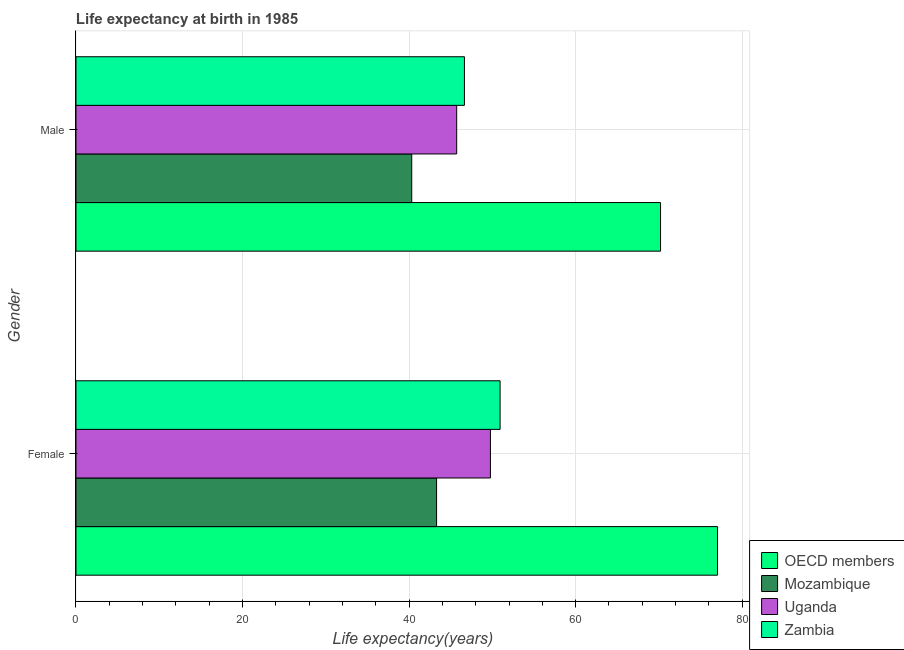How many different coloured bars are there?
Offer a very short reply. 4. Are the number of bars per tick equal to the number of legend labels?
Provide a succinct answer. Yes. How many bars are there on the 1st tick from the top?
Provide a succinct answer. 4. How many bars are there on the 1st tick from the bottom?
Provide a succinct answer. 4. What is the life expectancy(male) in Zambia?
Ensure brevity in your answer.  46.65. Across all countries, what is the maximum life expectancy(female)?
Provide a short and direct response. 77.03. Across all countries, what is the minimum life expectancy(female)?
Your response must be concise. 43.3. In which country was the life expectancy(male) minimum?
Give a very brief answer. Mozambique. What is the total life expectancy(female) in the graph?
Your response must be concise. 221.03. What is the difference between the life expectancy(female) in OECD members and that in Zambia?
Give a very brief answer. 26.11. What is the difference between the life expectancy(male) in Uganda and the life expectancy(female) in OECD members?
Provide a short and direct response. -31.32. What is the average life expectancy(male) per country?
Keep it short and to the point. 50.72. What is the difference between the life expectancy(female) and life expectancy(male) in OECD members?
Provide a short and direct response. 6.84. What is the ratio of the life expectancy(male) in Uganda to that in OECD members?
Give a very brief answer. 0.65. In how many countries, is the life expectancy(female) greater than the average life expectancy(female) taken over all countries?
Give a very brief answer. 1. What does the 1st bar from the top in Male represents?
Make the answer very short. Zambia. What does the 4th bar from the bottom in Male represents?
Offer a terse response. Zambia. How many bars are there?
Offer a terse response. 8. Are all the bars in the graph horizontal?
Your answer should be compact. Yes. How many countries are there in the graph?
Ensure brevity in your answer.  4. What is the difference between two consecutive major ticks on the X-axis?
Your answer should be very brief. 20. Does the graph contain grids?
Give a very brief answer. Yes. Where does the legend appear in the graph?
Ensure brevity in your answer.  Bottom right. How many legend labels are there?
Ensure brevity in your answer.  4. How are the legend labels stacked?
Your answer should be very brief. Vertical. What is the title of the graph?
Offer a terse response. Life expectancy at birth in 1985. Does "China" appear as one of the legend labels in the graph?
Your answer should be very brief. No. What is the label or title of the X-axis?
Your answer should be very brief. Life expectancy(years). What is the label or title of the Y-axis?
Keep it short and to the point. Gender. What is the Life expectancy(years) of OECD members in Female?
Make the answer very short. 77.03. What is the Life expectancy(years) of Mozambique in Female?
Give a very brief answer. 43.3. What is the Life expectancy(years) in Uganda in Female?
Your answer should be very brief. 49.77. What is the Life expectancy(years) in Zambia in Female?
Provide a short and direct response. 50.93. What is the Life expectancy(years) of OECD members in Male?
Your answer should be very brief. 70.19. What is the Life expectancy(years) of Mozambique in Male?
Make the answer very short. 40.32. What is the Life expectancy(years) of Uganda in Male?
Keep it short and to the point. 45.72. What is the Life expectancy(years) of Zambia in Male?
Ensure brevity in your answer.  46.65. Across all Gender, what is the maximum Life expectancy(years) of OECD members?
Make the answer very short. 77.03. Across all Gender, what is the maximum Life expectancy(years) of Mozambique?
Make the answer very short. 43.3. Across all Gender, what is the maximum Life expectancy(years) in Uganda?
Your response must be concise. 49.77. Across all Gender, what is the maximum Life expectancy(years) of Zambia?
Your answer should be compact. 50.93. Across all Gender, what is the minimum Life expectancy(years) in OECD members?
Your answer should be compact. 70.19. Across all Gender, what is the minimum Life expectancy(years) in Mozambique?
Your answer should be compact. 40.32. Across all Gender, what is the minimum Life expectancy(years) in Uganda?
Provide a succinct answer. 45.72. Across all Gender, what is the minimum Life expectancy(years) in Zambia?
Make the answer very short. 46.65. What is the total Life expectancy(years) of OECD members in the graph?
Make the answer very short. 147.23. What is the total Life expectancy(years) of Mozambique in the graph?
Your answer should be compact. 83.62. What is the total Life expectancy(years) of Uganda in the graph?
Offer a very short reply. 95.48. What is the total Life expectancy(years) of Zambia in the graph?
Offer a very short reply. 97.57. What is the difference between the Life expectancy(years) in OECD members in Female and that in Male?
Make the answer very short. 6.84. What is the difference between the Life expectancy(years) of Mozambique in Female and that in Male?
Keep it short and to the point. 2.98. What is the difference between the Life expectancy(years) of Uganda in Female and that in Male?
Offer a very short reply. 4.05. What is the difference between the Life expectancy(years) in Zambia in Female and that in Male?
Your answer should be compact. 4.28. What is the difference between the Life expectancy(years) of OECD members in Female and the Life expectancy(years) of Mozambique in Male?
Your answer should be compact. 36.72. What is the difference between the Life expectancy(years) of OECD members in Female and the Life expectancy(years) of Uganda in Male?
Keep it short and to the point. 31.32. What is the difference between the Life expectancy(years) in OECD members in Female and the Life expectancy(years) in Zambia in Male?
Provide a short and direct response. 30.39. What is the difference between the Life expectancy(years) in Mozambique in Female and the Life expectancy(years) in Uganda in Male?
Provide a succinct answer. -2.41. What is the difference between the Life expectancy(years) of Mozambique in Female and the Life expectancy(years) of Zambia in Male?
Provide a short and direct response. -3.35. What is the difference between the Life expectancy(years) in Uganda in Female and the Life expectancy(years) in Zambia in Male?
Provide a succinct answer. 3.12. What is the average Life expectancy(years) of OECD members per Gender?
Your answer should be very brief. 73.61. What is the average Life expectancy(years) of Mozambique per Gender?
Your answer should be compact. 41.81. What is the average Life expectancy(years) of Uganda per Gender?
Your answer should be very brief. 47.74. What is the average Life expectancy(years) of Zambia per Gender?
Provide a short and direct response. 48.79. What is the difference between the Life expectancy(years) of OECD members and Life expectancy(years) of Mozambique in Female?
Provide a succinct answer. 33.73. What is the difference between the Life expectancy(years) of OECD members and Life expectancy(years) of Uganda in Female?
Your answer should be very brief. 27.27. What is the difference between the Life expectancy(years) of OECD members and Life expectancy(years) of Zambia in Female?
Ensure brevity in your answer.  26.11. What is the difference between the Life expectancy(years) of Mozambique and Life expectancy(years) of Uganda in Female?
Provide a short and direct response. -6.46. What is the difference between the Life expectancy(years) of Mozambique and Life expectancy(years) of Zambia in Female?
Give a very brief answer. -7.63. What is the difference between the Life expectancy(years) of Uganda and Life expectancy(years) of Zambia in Female?
Give a very brief answer. -1.16. What is the difference between the Life expectancy(years) of OECD members and Life expectancy(years) of Mozambique in Male?
Offer a terse response. 29.88. What is the difference between the Life expectancy(years) of OECD members and Life expectancy(years) of Uganda in Male?
Give a very brief answer. 24.48. What is the difference between the Life expectancy(years) in OECD members and Life expectancy(years) in Zambia in Male?
Ensure brevity in your answer.  23.55. What is the difference between the Life expectancy(years) in Mozambique and Life expectancy(years) in Uganda in Male?
Your answer should be compact. -5.4. What is the difference between the Life expectancy(years) of Mozambique and Life expectancy(years) of Zambia in Male?
Your answer should be compact. -6.33. What is the difference between the Life expectancy(years) in Uganda and Life expectancy(years) in Zambia in Male?
Offer a very short reply. -0.93. What is the ratio of the Life expectancy(years) of OECD members in Female to that in Male?
Provide a short and direct response. 1.1. What is the ratio of the Life expectancy(years) of Mozambique in Female to that in Male?
Provide a succinct answer. 1.07. What is the ratio of the Life expectancy(years) in Uganda in Female to that in Male?
Offer a terse response. 1.09. What is the ratio of the Life expectancy(years) in Zambia in Female to that in Male?
Your response must be concise. 1.09. What is the difference between the highest and the second highest Life expectancy(years) of OECD members?
Ensure brevity in your answer.  6.84. What is the difference between the highest and the second highest Life expectancy(years) in Mozambique?
Your response must be concise. 2.98. What is the difference between the highest and the second highest Life expectancy(years) of Uganda?
Give a very brief answer. 4.05. What is the difference between the highest and the second highest Life expectancy(years) of Zambia?
Your answer should be very brief. 4.28. What is the difference between the highest and the lowest Life expectancy(years) of OECD members?
Ensure brevity in your answer.  6.84. What is the difference between the highest and the lowest Life expectancy(years) in Mozambique?
Your answer should be very brief. 2.98. What is the difference between the highest and the lowest Life expectancy(years) of Uganda?
Make the answer very short. 4.05. What is the difference between the highest and the lowest Life expectancy(years) of Zambia?
Your answer should be very brief. 4.28. 